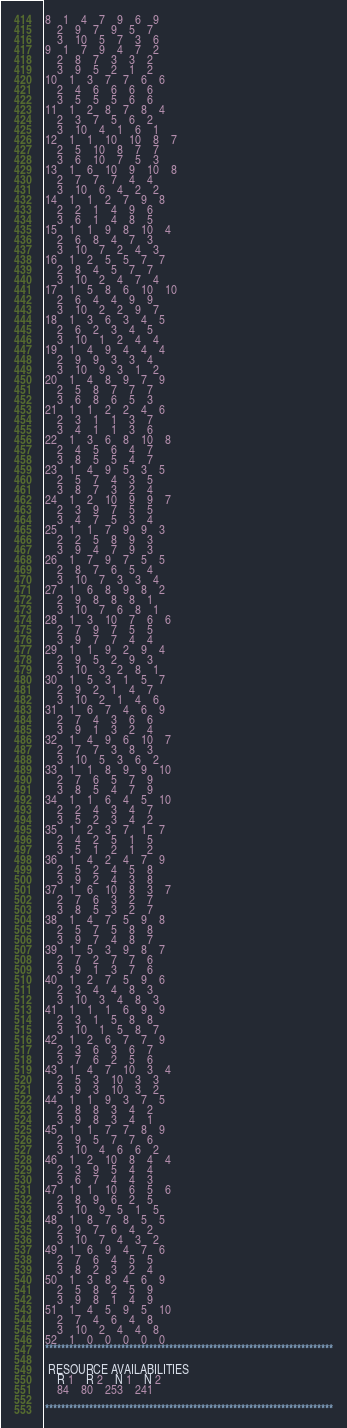Convert code to text. <code><loc_0><loc_0><loc_500><loc_500><_ObjectiveC_>8	1	4	7	9	6	9	
	2	9	7	9	5	7	
	3	10	5	7	3	6	
9	1	7	9	4	7	2	
	2	8	7	3	3	2	
	3	9	5	2	1	2	
10	1	3	7	7	6	6	
	2	4	6	6	6	6	
	3	5	5	5	6	6	
11	1	2	8	7	8	4	
	2	3	7	5	6	2	
	3	10	4	1	6	1	
12	1	1	10	10	8	7	
	2	5	10	8	7	7	
	3	6	10	7	5	3	
13	1	6	10	9	10	8	
	2	7	7	7	4	4	
	3	10	6	4	2	2	
14	1	1	2	7	9	8	
	2	2	1	4	9	6	
	3	6	1	4	8	5	
15	1	1	9	8	10	4	
	2	6	8	4	7	3	
	3	10	7	2	4	3	
16	1	2	5	5	7	7	
	2	8	4	5	7	7	
	3	10	2	4	7	4	
17	1	5	8	6	10	10	
	2	6	4	4	9	9	
	3	10	2	2	9	7	
18	1	3	6	3	4	5	
	2	6	2	3	4	5	
	3	10	1	2	4	4	
19	1	4	9	4	4	4	
	2	9	9	3	3	4	
	3	10	9	3	1	2	
20	1	4	8	9	7	9	
	2	5	8	7	7	7	
	3	6	8	6	5	3	
21	1	1	2	2	4	6	
	2	3	1	1	3	7	
	3	4	1	1	3	6	
22	1	3	6	8	10	8	
	2	4	5	6	4	7	
	3	8	5	5	4	7	
23	1	4	9	5	3	5	
	2	5	7	4	3	5	
	3	8	7	3	2	4	
24	1	2	10	9	9	7	
	2	3	9	7	5	5	
	3	4	7	5	3	4	
25	1	1	7	9	9	3	
	2	2	5	8	9	3	
	3	9	4	7	9	3	
26	1	7	9	7	5	5	
	2	8	7	6	5	4	
	3	10	7	3	3	4	
27	1	6	8	9	8	2	
	2	9	8	8	8	1	
	3	10	7	6	8	1	
28	1	3	10	7	6	6	
	2	7	9	7	5	5	
	3	9	7	7	4	4	
29	1	1	9	2	9	4	
	2	9	5	2	9	3	
	3	10	3	2	8	1	
30	1	5	3	1	5	7	
	2	9	2	1	4	7	
	3	10	2	1	4	6	
31	1	6	7	4	6	9	
	2	7	4	3	6	6	
	3	9	1	3	2	4	
32	1	4	9	6	10	7	
	2	7	7	3	8	3	
	3	10	5	3	6	2	
33	1	1	8	9	9	10	
	2	7	6	5	7	9	
	3	8	5	4	7	9	
34	1	1	6	4	5	10	
	2	2	4	3	4	7	
	3	5	2	3	4	2	
35	1	2	3	7	1	7	
	2	4	2	5	1	5	
	3	5	1	2	1	2	
36	1	4	2	4	7	9	
	2	5	2	4	5	8	
	3	9	2	4	3	8	
37	1	6	10	8	3	7	
	2	7	6	3	2	7	
	3	8	5	3	2	7	
38	1	4	7	5	9	8	
	2	5	7	5	8	8	
	3	9	7	4	8	7	
39	1	5	3	9	8	7	
	2	7	2	7	7	6	
	3	9	1	3	7	6	
40	1	2	7	5	9	6	
	2	3	4	4	8	3	
	3	10	3	4	8	3	
41	1	1	1	6	9	9	
	2	3	1	5	8	8	
	3	10	1	5	8	7	
42	1	2	6	7	7	9	
	2	3	6	3	6	7	
	3	7	6	2	5	6	
43	1	4	7	10	3	4	
	2	5	3	10	3	3	
	3	9	3	10	3	2	
44	1	1	9	3	7	5	
	2	8	8	3	4	2	
	3	9	8	3	4	1	
45	1	1	7	7	8	9	
	2	9	5	7	7	6	
	3	10	4	6	6	2	
46	1	2	10	8	4	4	
	2	3	9	5	4	4	
	3	6	7	4	4	3	
47	1	1	10	6	5	6	
	2	8	9	6	2	5	
	3	10	9	5	1	5	
48	1	8	7	8	5	5	
	2	9	7	6	4	2	
	3	10	7	4	3	2	
49	1	6	9	4	7	6	
	2	7	6	4	5	5	
	3	8	2	3	2	4	
50	1	3	8	4	6	9	
	2	5	8	2	5	9	
	3	9	8	1	4	9	
51	1	4	5	9	5	10	
	2	7	4	6	4	8	
	3	10	2	4	4	8	
52	1	0	0	0	0	0	
************************************************************************

 RESOURCE AVAILABILITIES 
	R 1	R 2	N 1	N 2
	84	80	253	241

************************************************************************
</code> 